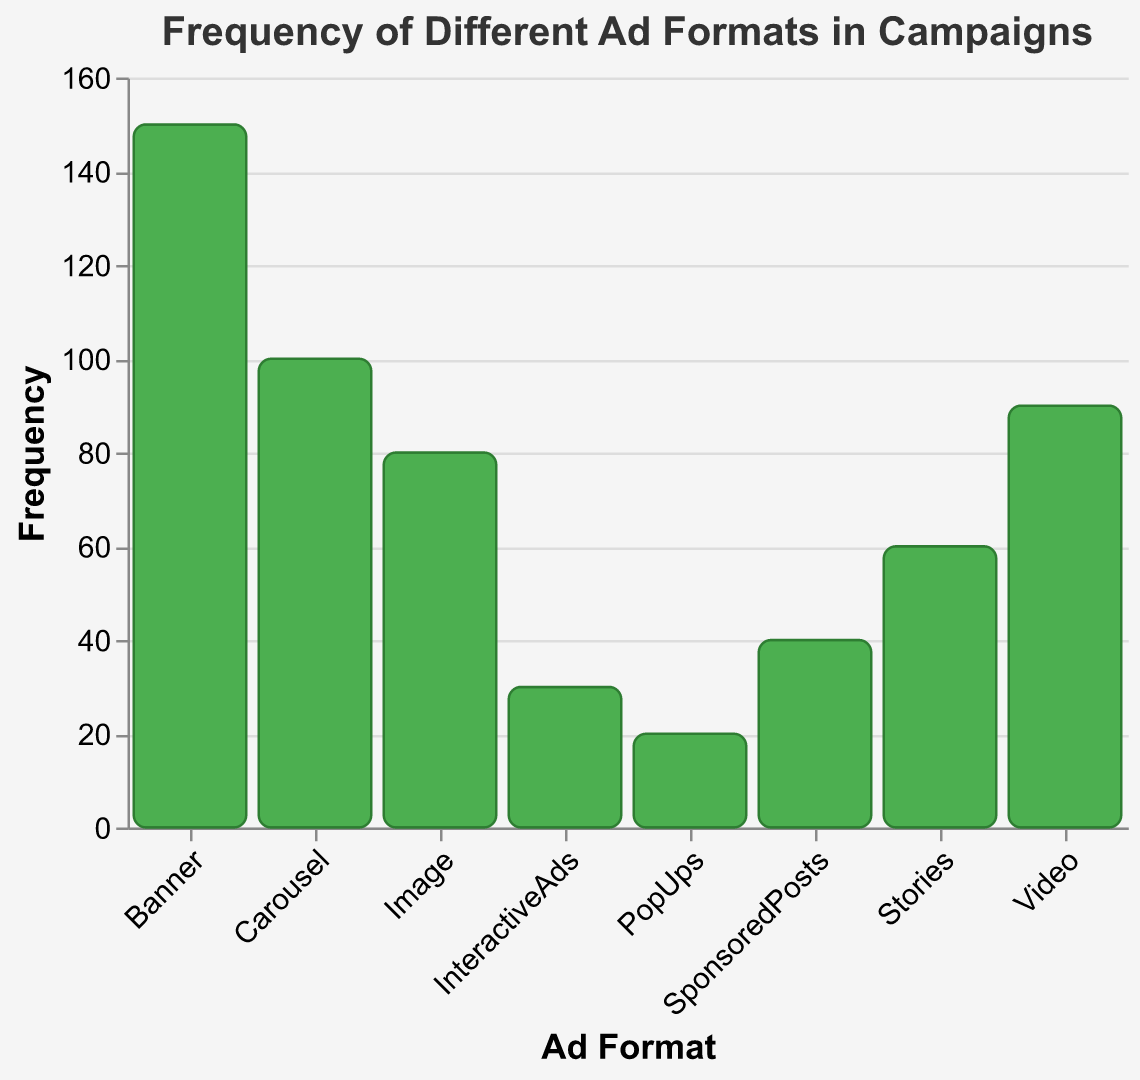What is the title of the figure? The title of the figure is displayed at the top center. It reads, "Frequency of Different Ad Formats in Campaigns".
Answer: "Frequency of Different Ad Formats in Campaigns" What are the labels for the x and y axes? The x-axis is labeled "Ad Format" and the y-axis is labeled "Frequency".
Answer: "Ad Format" and "Frequency" Which ad format has the highest frequency? By looking at the heights of the bars, the "Banner" ad format has the highest frequency at 150.
Answer: Banner How many ad formats have a frequency higher than 80? By visually inspecting the heights of the bars, four ad formats have a frequency higher than 80: Banner, Video, Carousel, and Image.
Answer: 4 Calculate the average frequency of all the ad formats. Sum all the frequencies (150 + 90 + 100 + 80 + 60 + 40 + 30 + 20 = 570) and divide by the number of ad formats (8), so the average is 570 / 8 = 71.25.
Answer: 71.25 How much higher is the frequency of the "Banner" ad format compared to "PopUps"? The "Banner" frequency is 150, and "PopUps" frequency is 20. The difference is 150 - 20 = 130.
Answer: 130 What is the total frequency of Carousel and Stories combined? Add the frequencies of Carousel (100) and Stories (60). The total is 100 + 60 = 160.
Answer: 160 Which ad format has the lowest frequency, and what is its value? The "PopUps" ad format has the lowest frequency, which is 20.
Answer: PopUps, 20 Rank the ad formats from highest to lowest frequency. Arrange the ad formats based on the bar heights: Banner (150), Carousel (100), Video (90), Image (80), Stories (60), SponsoredPosts (40), InteractiveAds (30), PopUps (20).
Answer: Banner, Carousel, Video, Image, Stories, SponsoredPosts, InteractiveAds, PopUps Identify the ad formats that have a frequency of exactly 100. The ad format with a frequency of exactly 100 is "Carousel".
Answer: Carousel 